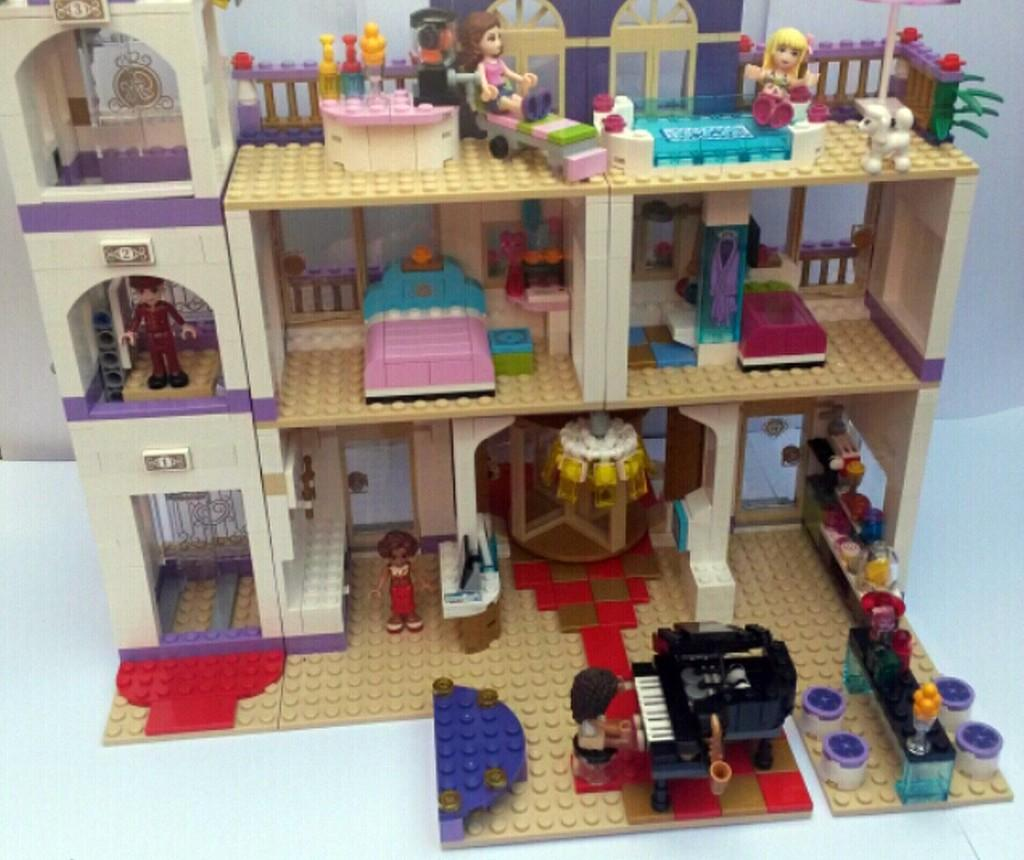What type of structure is present in the image? The image contains a building. What material is the building made of? The building is constructed using Lego. What is the color of the building's surface? The surface of the building is white. What can be seen in the background of the image? There is a wall in the background of the image. What is the color of the wall? The wall is painted white. What type of writing can be seen on the corn in the image? There is no corn present in the image, and therefore no writing can be seen on it. 